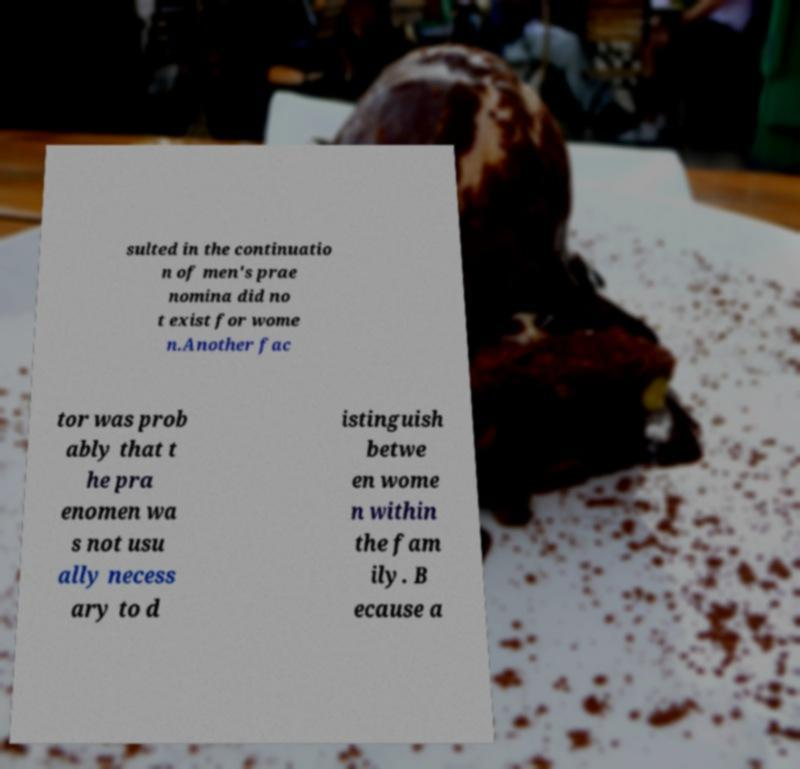Can you read and provide the text displayed in the image?This photo seems to have some interesting text. Can you extract and type it out for me? sulted in the continuatio n of men's prae nomina did no t exist for wome n.Another fac tor was prob ably that t he pra enomen wa s not usu ally necess ary to d istinguish betwe en wome n within the fam ily. B ecause a 